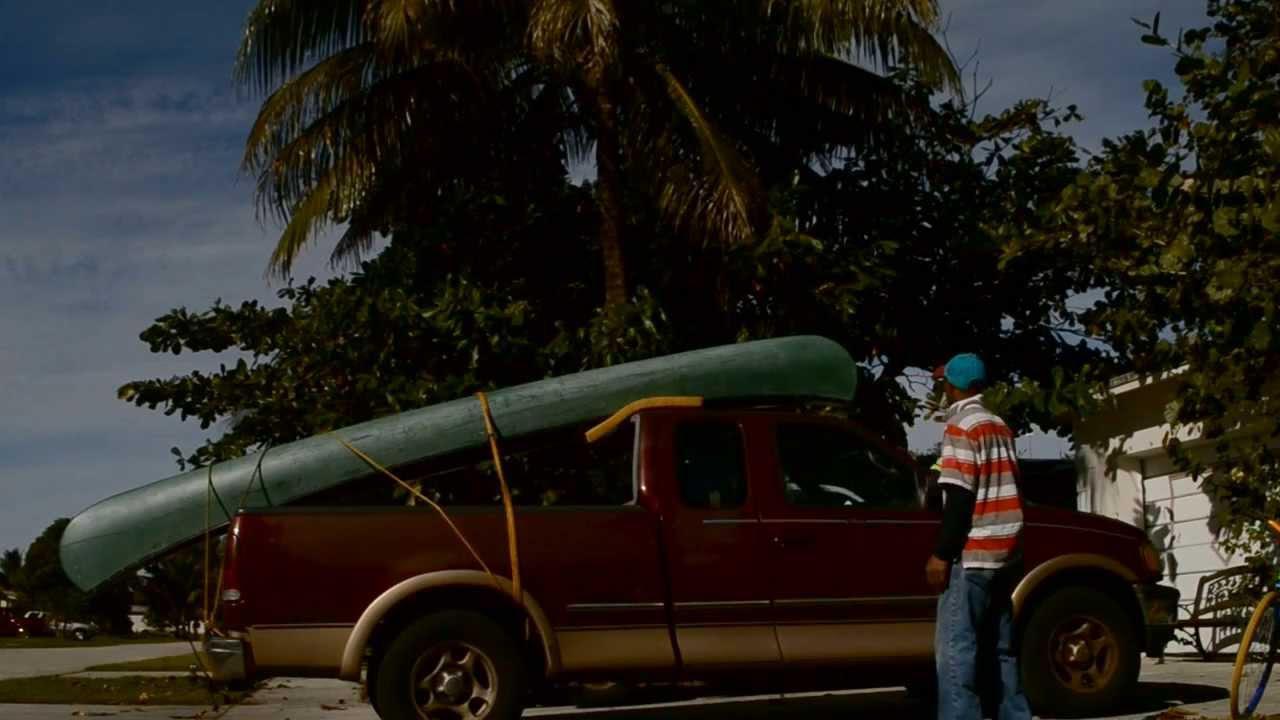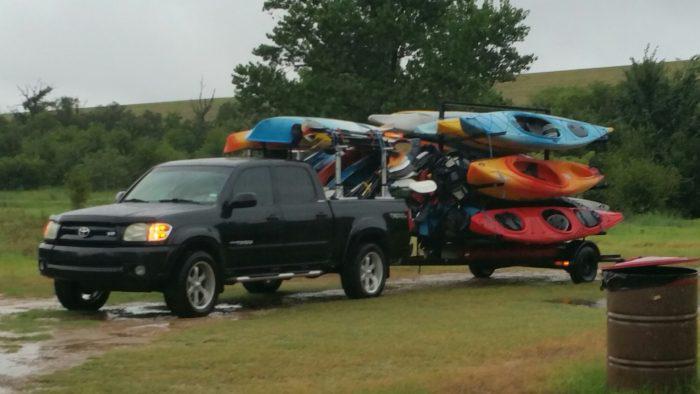The first image is the image on the left, the second image is the image on the right. Assess this claim about the two images: "In the right image there is a truck driving to the left in the daytime.". Correct or not? Answer yes or no. Yes. 